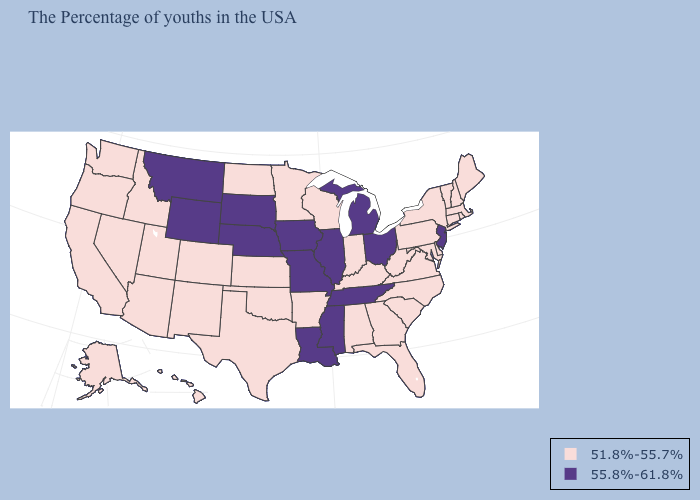Does Montana have the highest value in the USA?
Concise answer only. Yes. Name the states that have a value in the range 51.8%-55.7%?
Give a very brief answer. Maine, Massachusetts, Rhode Island, New Hampshire, Vermont, Connecticut, New York, Delaware, Maryland, Pennsylvania, Virginia, North Carolina, South Carolina, West Virginia, Florida, Georgia, Kentucky, Indiana, Alabama, Wisconsin, Arkansas, Minnesota, Kansas, Oklahoma, Texas, North Dakota, Colorado, New Mexico, Utah, Arizona, Idaho, Nevada, California, Washington, Oregon, Alaska, Hawaii. What is the value of Mississippi?
Give a very brief answer. 55.8%-61.8%. Name the states that have a value in the range 55.8%-61.8%?
Keep it brief. New Jersey, Ohio, Michigan, Tennessee, Illinois, Mississippi, Louisiana, Missouri, Iowa, Nebraska, South Dakota, Wyoming, Montana. What is the highest value in states that border North Carolina?
Be succinct. 55.8%-61.8%. Does California have a higher value than Florida?
Write a very short answer. No. What is the value of North Dakota?
Write a very short answer. 51.8%-55.7%. Is the legend a continuous bar?
Concise answer only. No. What is the highest value in the West ?
Answer briefly. 55.8%-61.8%. What is the highest value in the West ?
Quick response, please. 55.8%-61.8%. Does Arizona have the highest value in the USA?
Be succinct. No. Does New Jersey have the highest value in the Northeast?
Quick response, please. Yes. Name the states that have a value in the range 51.8%-55.7%?
Keep it brief. Maine, Massachusetts, Rhode Island, New Hampshire, Vermont, Connecticut, New York, Delaware, Maryland, Pennsylvania, Virginia, North Carolina, South Carolina, West Virginia, Florida, Georgia, Kentucky, Indiana, Alabama, Wisconsin, Arkansas, Minnesota, Kansas, Oklahoma, Texas, North Dakota, Colorado, New Mexico, Utah, Arizona, Idaho, Nevada, California, Washington, Oregon, Alaska, Hawaii. Among the states that border Florida , which have the lowest value?
Answer briefly. Georgia, Alabama. Name the states that have a value in the range 55.8%-61.8%?
Write a very short answer. New Jersey, Ohio, Michigan, Tennessee, Illinois, Mississippi, Louisiana, Missouri, Iowa, Nebraska, South Dakota, Wyoming, Montana. 